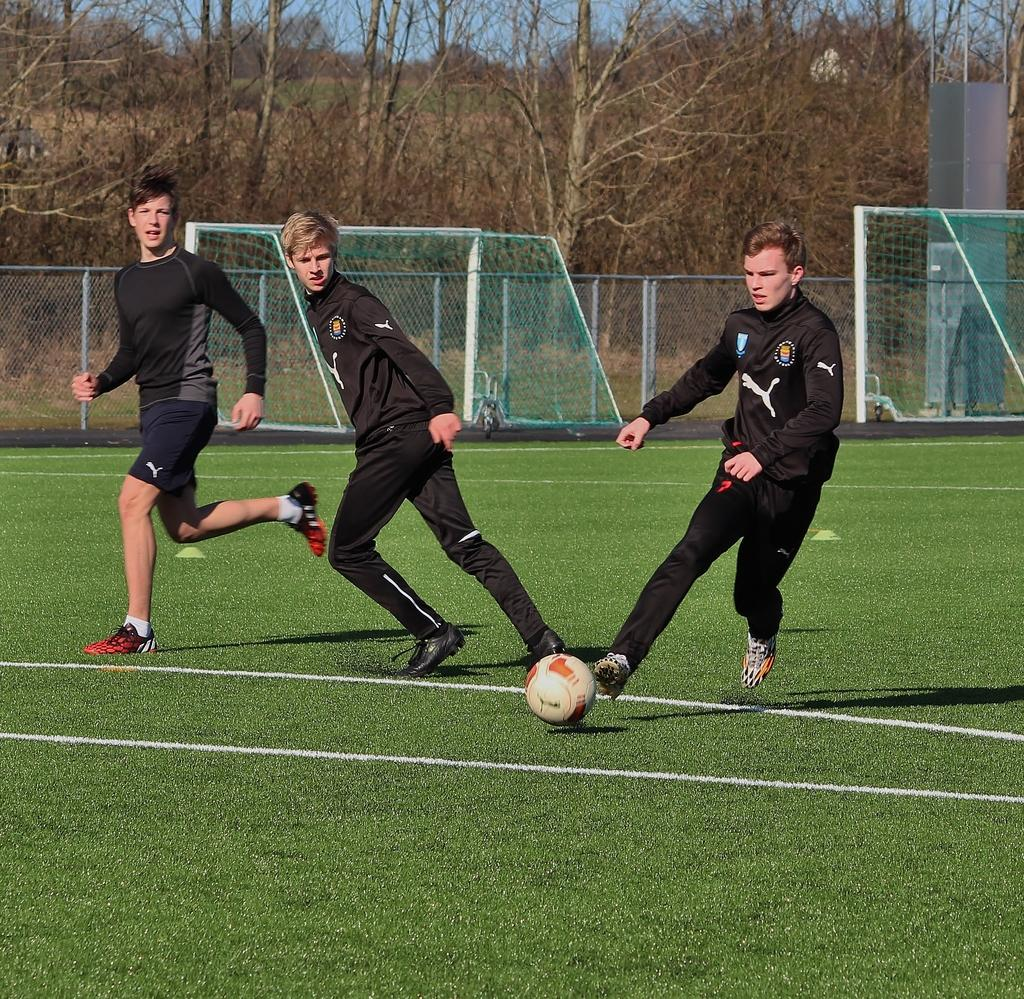How many people are in the image? There is a group of persons in the image. What are the persons in the image doing? The persons are running on the ground. What object is in front of the group? There is a ball in front of the group. What is located at the back of the group? There is fencing at the back of the group. What type of vegetation can be seen in the image? Trees are present in the image. What type of milk is being poured over the trees in the image? There is no milk present in the image, and therefore no such activity can be observed. 